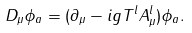Convert formula to latex. <formula><loc_0><loc_0><loc_500><loc_500>D _ { \mu } \phi _ { a } = ( \partial _ { \mu } - i g T ^ { l } A ^ { l } _ { \mu } ) \phi _ { a } .</formula> 